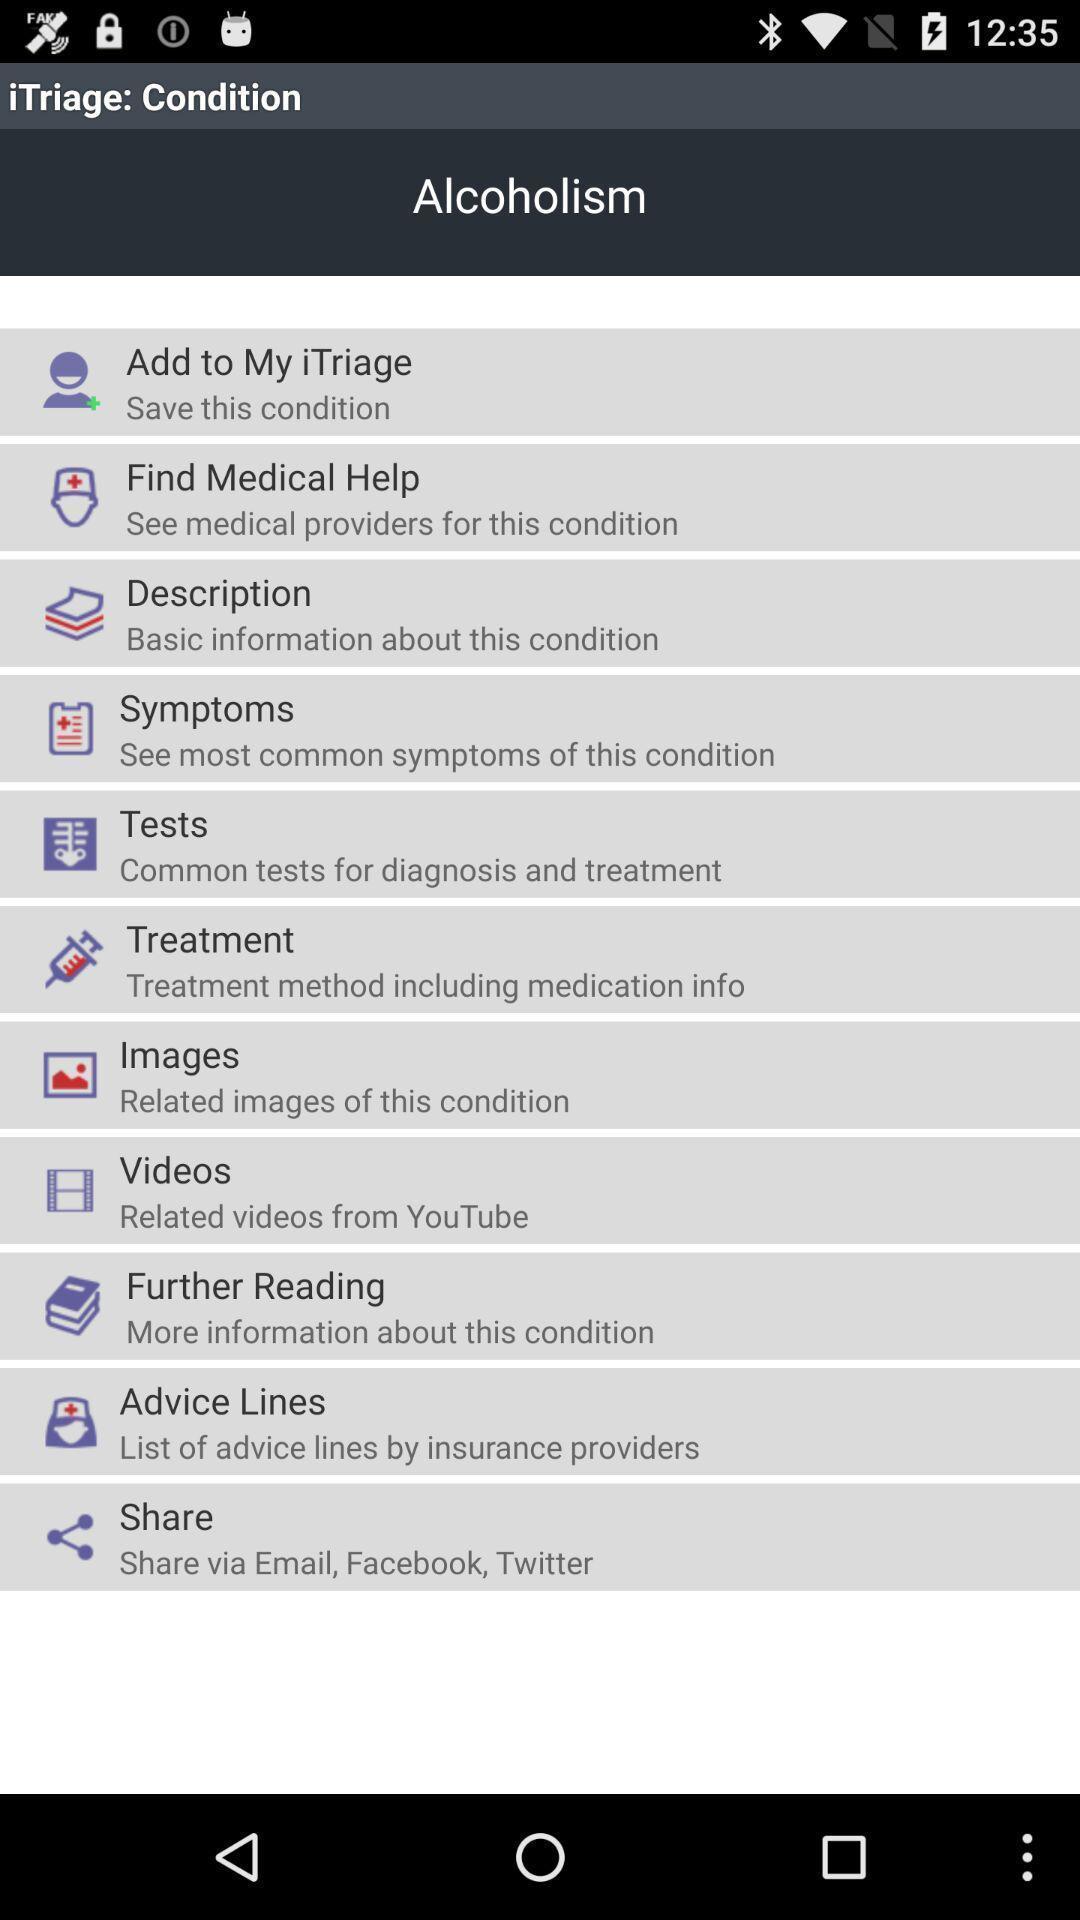Provide a detailed account of this screenshot. Page displaying various options for a medical condition. 